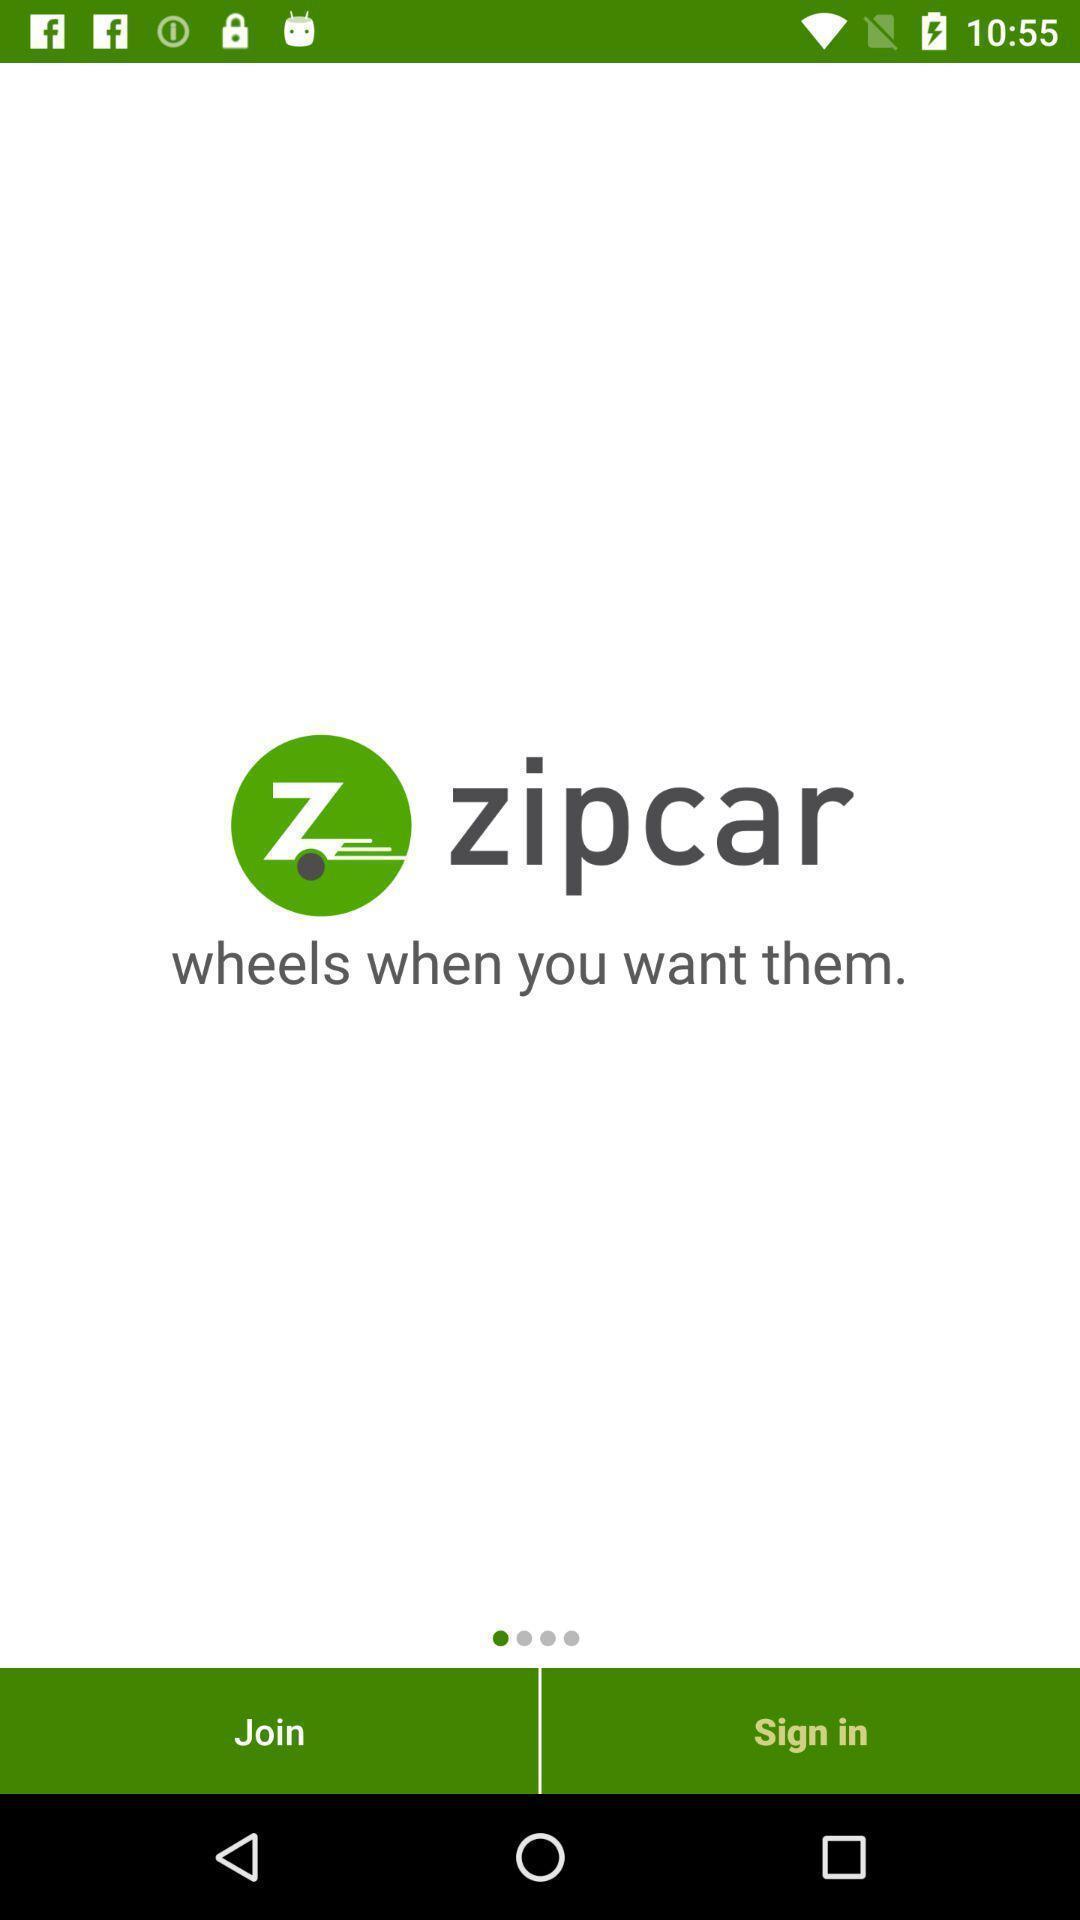What is the overall content of this screenshot? Sign in page. 